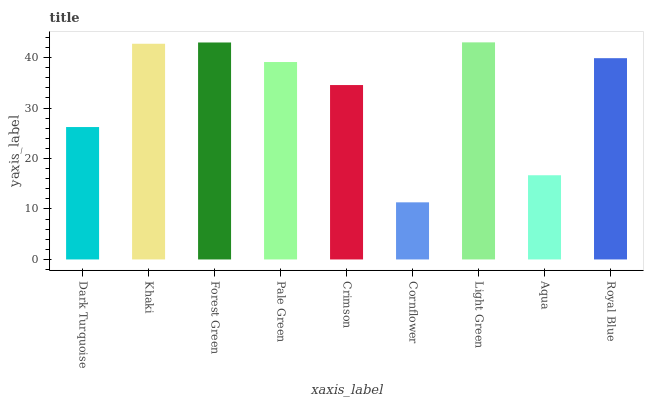Is Cornflower the minimum?
Answer yes or no. Yes. Is Light Green the maximum?
Answer yes or no. Yes. Is Khaki the minimum?
Answer yes or no. No. Is Khaki the maximum?
Answer yes or no. No. Is Khaki greater than Dark Turquoise?
Answer yes or no. Yes. Is Dark Turquoise less than Khaki?
Answer yes or no. Yes. Is Dark Turquoise greater than Khaki?
Answer yes or no. No. Is Khaki less than Dark Turquoise?
Answer yes or no. No. Is Pale Green the high median?
Answer yes or no. Yes. Is Pale Green the low median?
Answer yes or no. Yes. Is Crimson the high median?
Answer yes or no. No. Is Crimson the low median?
Answer yes or no. No. 